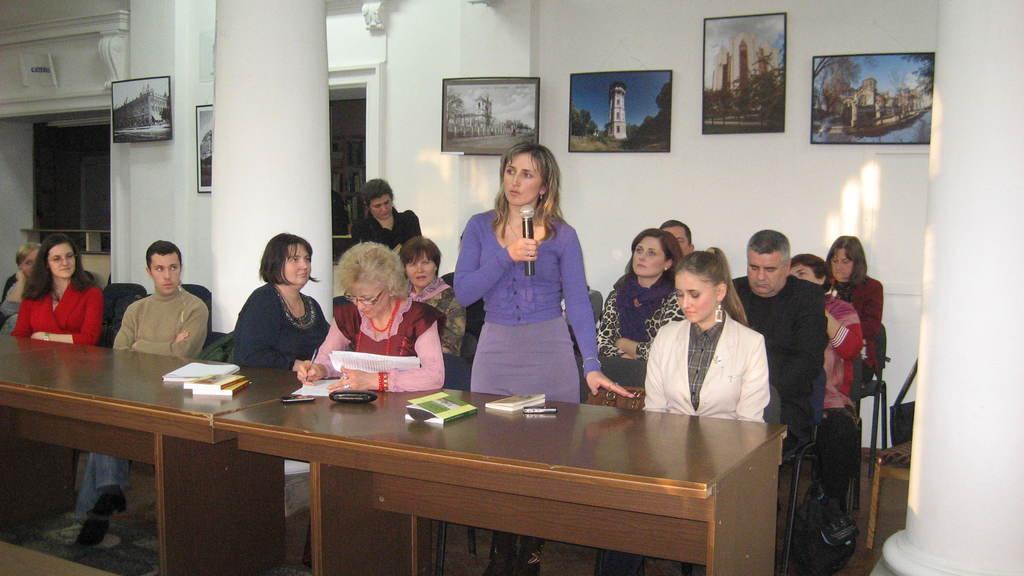In one or two sentences, can you explain what this image depicts? This picture describes about group of people few are seated on the chair and few are standing, in the middle of the image a woman is standing and she is holding a microphone in her hands, in the background we can see couple of wall paintings. 